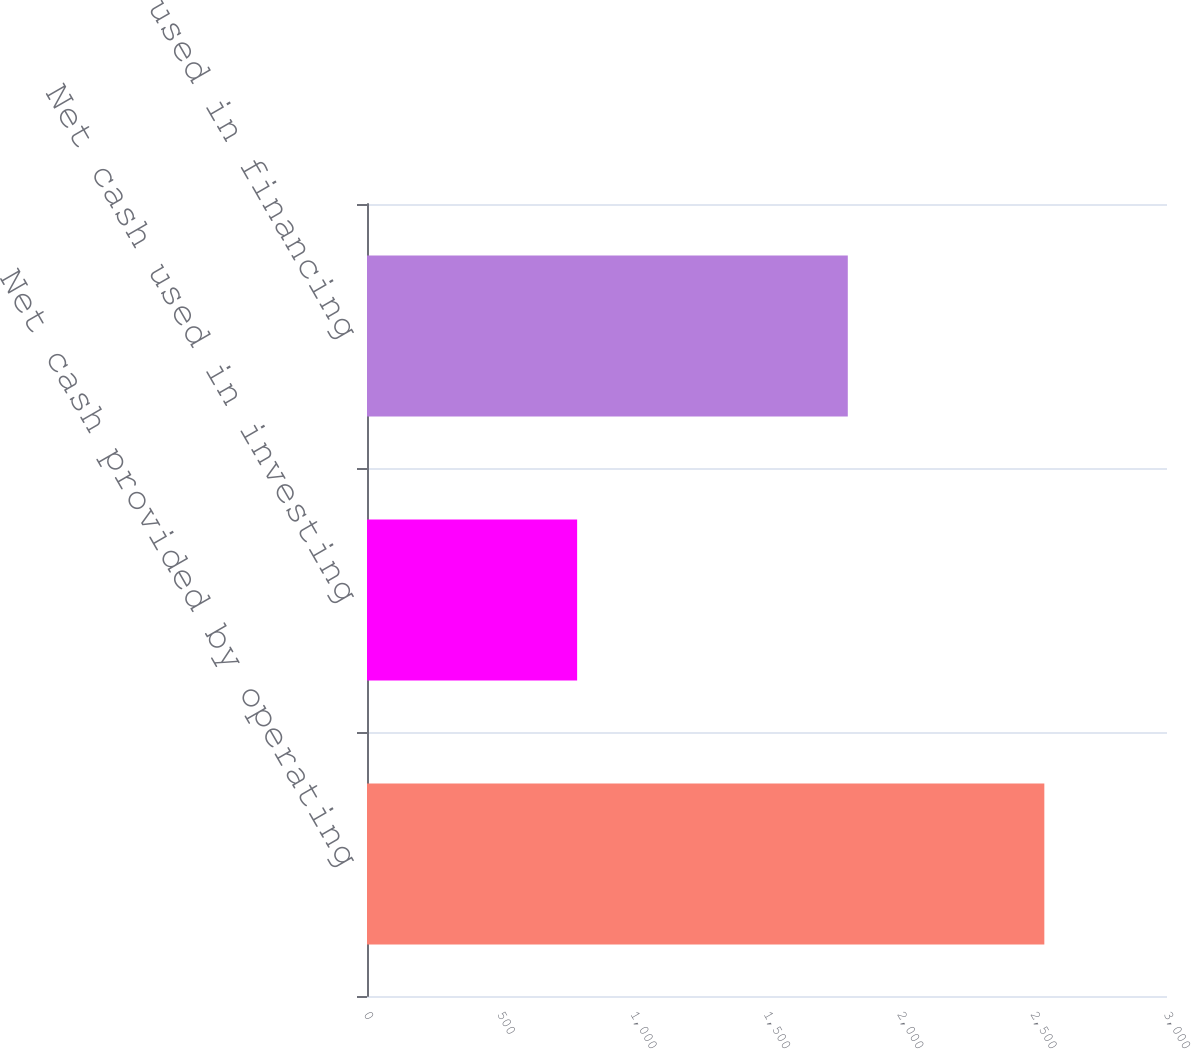<chart> <loc_0><loc_0><loc_500><loc_500><bar_chart><fcel>Net cash provided by operating<fcel>Net cash used in investing<fcel>Net cash used in financing<nl><fcel>2540<fcel>788<fcel>1803<nl></chart> 